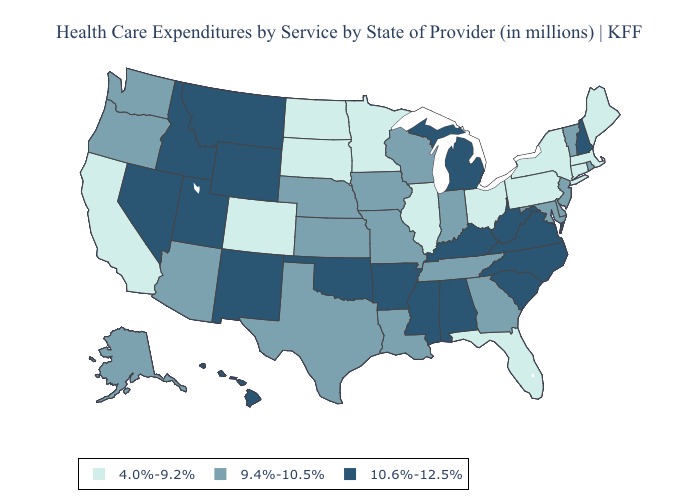Among the states that border Washington , which have the highest value?
Give a very brief answer. Idaho. What is the highest value in the MidWest ?
Answer briefly. 10.6%-12.5%. What is the lowest value in the MidWest?
Concise answer only. 4.0%-9.2%. What is the highest value in states that border Louisiana?
Give a very brief answer. 10.6%-12.5%. What is the lowest value in states that border Oklahoma?
Short answer required. 4.0%-9.2%. What is the value of Nevada?
Answer briefly. 10.6%-12.5%. Does Texas have the same value as Kansas?
Write a very short answer. Yes. Which states have the highest value in the USA?
Concise answer only. Alabama, Arkansas, Hawaii, Idaho, Kentucky, Michigan, Mississippi, Montana, Nevada, New Hampshire, New Mexico, North Carolina, Oklahoma, South Carolina, Utah, Virginia, West Virginia, Wyoming. Does Minnesota have the same value as Idaho?
Keep it brief. No. Name the states that have a value in the range 9.4%-10.5%?
Quick response, please. Alaska, Arizona, Delaware, Georgia, Indiana, Iowa, Kansas, Louisiana, Maryland, Missouri, Nebraska, New Jersey, Oregon, Rhode Island, Tennessee, Texas, Vermont, Washington, Wisconsin. What is the highest value in states that border North Carolina?
Quick response, please. 10.6%-12.5%. Does Colorado have the highest value in the USA?
Give a very brief answer. No. What is the lowest value in the USA?
Keep it brief. 4.0%-9.2%. What is the highest value in the USA?
Quick response, please. 10.6%-12.5%. 